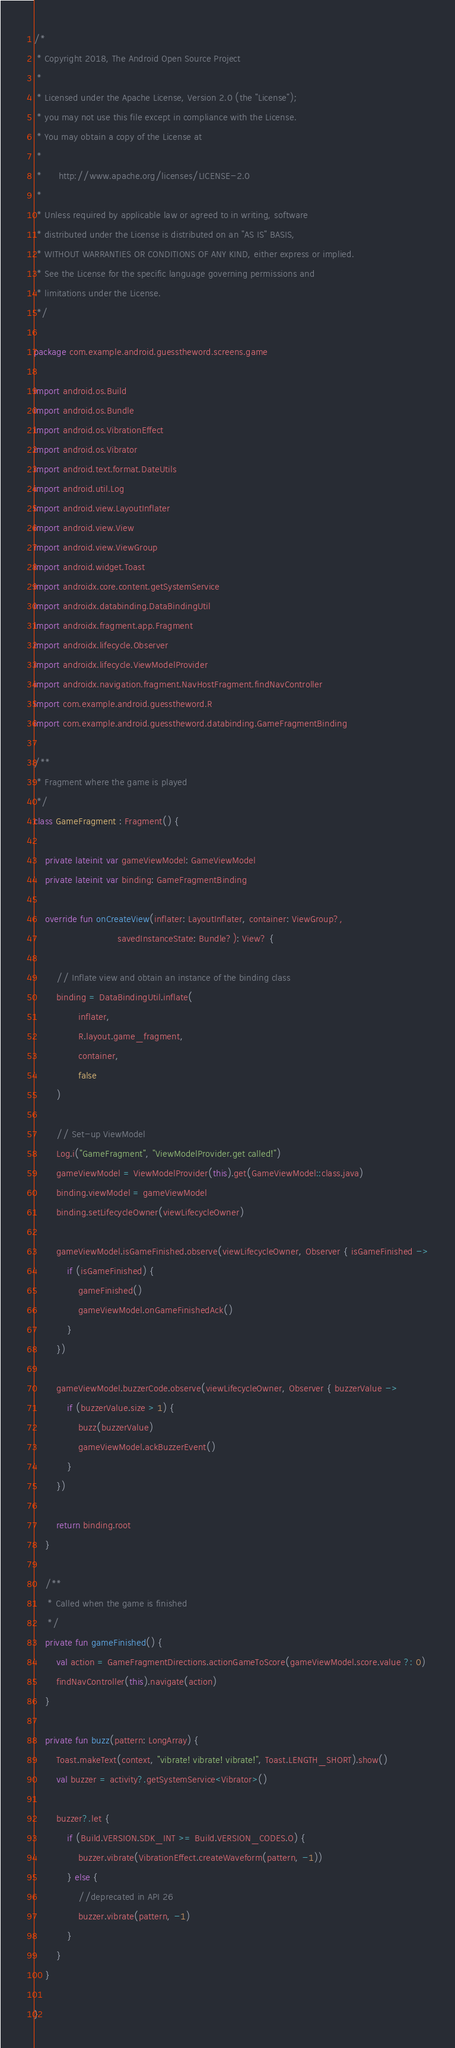Convert code to text. <code><loc_0><loc_0><loc_500><loc_500><_Kotlin_>/*
 * Copyright 2018, The Android Open Source Project
 *
 * Licensed under the Apache License, Version 2.0 (the "License");
 * you may not use this file except in compliance with the License.
 * You may obtain a copy of the License at
 *
 *      http://www.apache.org/licenses/LICENSE-2.0
 *
 * Unless required by applicable law or agreed to in writing, software
 * distributed under the License is distributed on an "AS IS" BASIS,
 * WITHOUT WARRANTIES OR CONDITIONS OF ANY KIND, either express or implied.
 * See the License for the specific language governing permissions and
 * limitations under the License.
 */

package com.example.android.guesstheword.screens.game

import android.os.Build
import android.os.Bundle
import android.os.VibrationEffect
import android.os.Vibrator
import android.text.format.DateUtils
import android.util.Log
import android.view.LayoutInflater
import android.view.View
import android.view.ViewGroup
import android.widget.Toast
import androidx.core.content.getSystemService
import androidx.databinding.DataBindingUtil
import androidx.fragment.app.Fragment
import androidx.lifecycle.Observer
import androidx.lifecycle.ViewModelProvider
import androidx.navigation.fragment.NavHostFragment.findNavController
import com.example.android.guesstheword.R
import com.example.android.guesstheword.databinding.GameFragmentBinding

/**
 * Fragment where the game is played
 */
class GameFragment : Fragment() {

    private lateinit var gameViewModel: GameViewModel
    private lateinit var binding: GameFragmentBinding

    override fun onCreateView(inflater: LayoutInflater, container: ViewGroup?,
                              savedInstanceState: Bundle?): View? {

        // Inflate view and obtain an instance of the binding class
        binding = DataBindingUtil.inflate(
                inflater,
                R.layout.game_fragment,
                container,
                false
        )

        // Set-up ViewModel
        Log.i("GameFragment", "ViewModelProvider.get called!")
        gameViewModel = ViewModelProvider(this).get(GameViewModel::class.java)
        binding.viewModel = gameViewModel
        binding.setLifecycleOwner(viewLifecycleOwner)

        gameViewModel.isGameFinished.observe(viewLifecycleOwner, Observer { isGameFinished ->
            if (isGameFinished) {
                gameFinished()
                gameViewModel.onGameFinishedAck()
            }
        })

        gameViewModel.buzzerCode.observe(viewLifecycleOwner, Observer { buzzerValue ->
            if (buzzerValue.size > 1) {
                buzz(buzzerValue)
                gameViewModel.ackBuzzerEvent()
            }
        })

        return binding.root
    }

    /**
     * Called when the game is finished
     */
    private fun gameFinished() {
        val action = GameFragmentDirections.actionGameToScore(gameViewModel.score.value ?: 0)
        findNavController(this).navigate(action)
    }

    private fun buzz(pattern: LongArray) {
        Toast.makeText(context, "vibrate! vibrate! vibrate!", Toast.LENGTH_SHORT).show()
        val buzzer = activity?.getSystemService<Vibrator>()

        buzzer?.let {
            if (Build.VERSION.SDK_INT >= Build.VERSION_CODES.O) {
                buzzer.vibrate(VibrationEffect.createWaveform(pattern, -1))
            } else {
                //deprecated in API 26
                buzzer.vibrate(pattern, -1)
            }
        }
    }

}
</code> 